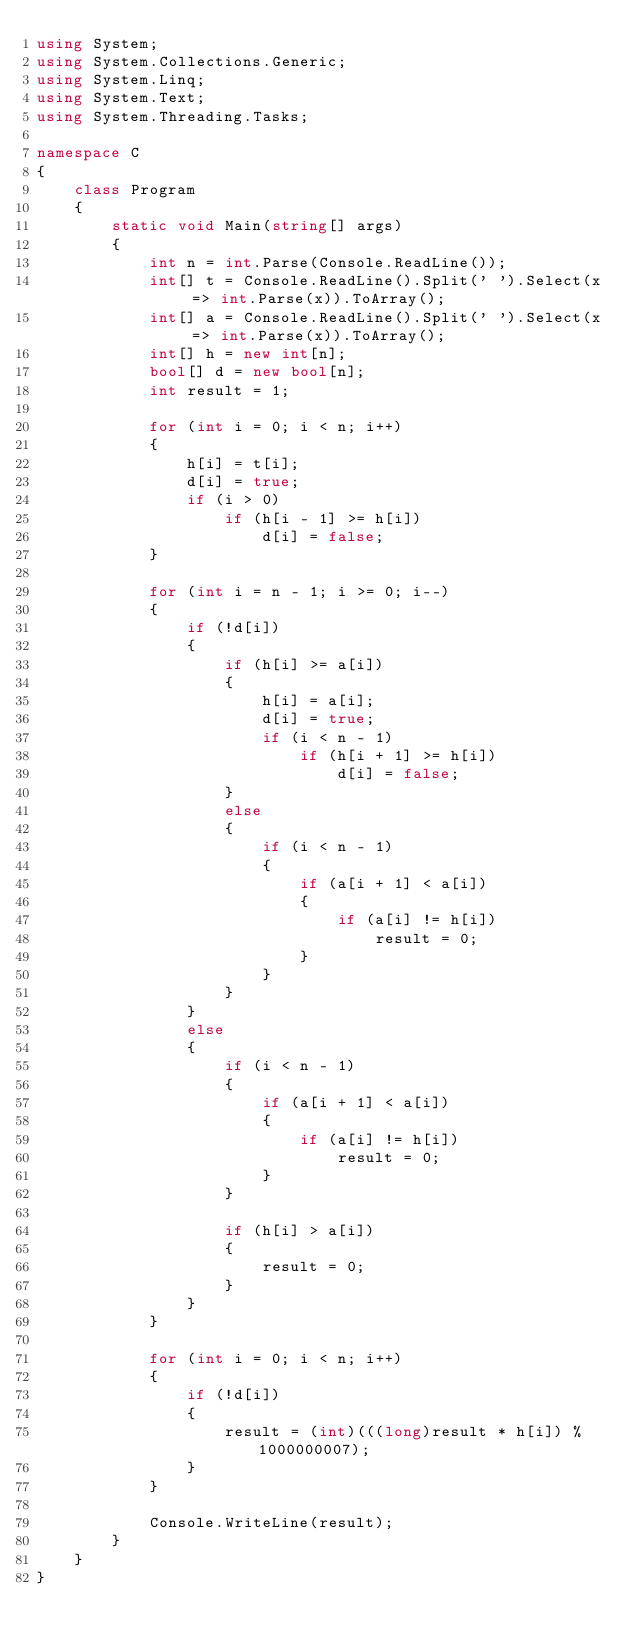Convert code to text. <code><loc_0><loc_0><loc_500><loc_500><_C#_>using System;
using System.Collections.Generic;
using System.Linq;
using System.Text;
using System.Threading.Tasks;

namespace C
{
    class Program
    {
        static void Main(string[] args)
        {
            int n = int.Parse(Console.ReadLine());
            int[] t = Console.ReadLine().Split(' ').Select(x => int.Parse(x)).ToArray();
            int[] a = Console.ReadLine().Split(' ').Select(x => int.Parse(x)).ToArray();
            int[] h = new int[n];
            bool[] d = new bool[n];
            int result = 1;

            for (int i = 0; i < n; i++)
            {
                h[i] = t[i];
                d[i] = true;
                if (i > 0)
                    if (h[i - 1] >= h[i])
                        d[i] = false;
            }

            for (int i = n - 1; i >= 0; i--)
            {
                if (!d[i])
                {
                    if (h[i] >= a[i])
                    {
                        h[i] = a[i];
                        d[i] = true;
                        if (i < n - 1)
                            if (h[i + 1] >= h[i])
                                d[i] = false;
                    }
                    else
                    {
                        if (i < n - 1)
                        {
                            if (a[i + 1] < a[i])
                            {
                                if (a[i] != h[i])
                                    result = 0;
                            }
                        }
                    }
                }
                else
                {
                    if (i < n - 1)
                    {
                        if (a[i + 1] < a[i])
                        {
                            if (a[i] != h[i])
                                result = 0;
                        }
                    }

                    if (h[i] > a[i])
                    {
                        result = 0;
                    }
                }
            }

            for (int i = 0; i < n; i++)
            {
                if (!d[i])
                {
                    result = (int)(((long)result * h[i]) % 1000000007);
                }
            }

            Console.WriteLine(result);
        }
    }
}
</code> 